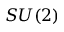Convert formula to latex. <formula><loc_0><loc_0><loc_500><loc_500>S U ( 2 )</formula> 